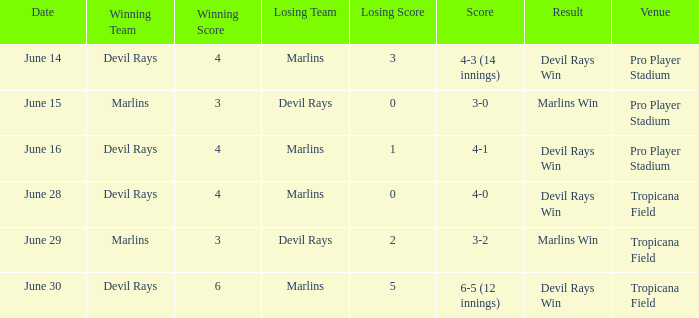What was the score of the game at pro player stadium on june 14? 4-3 (14 innings). 